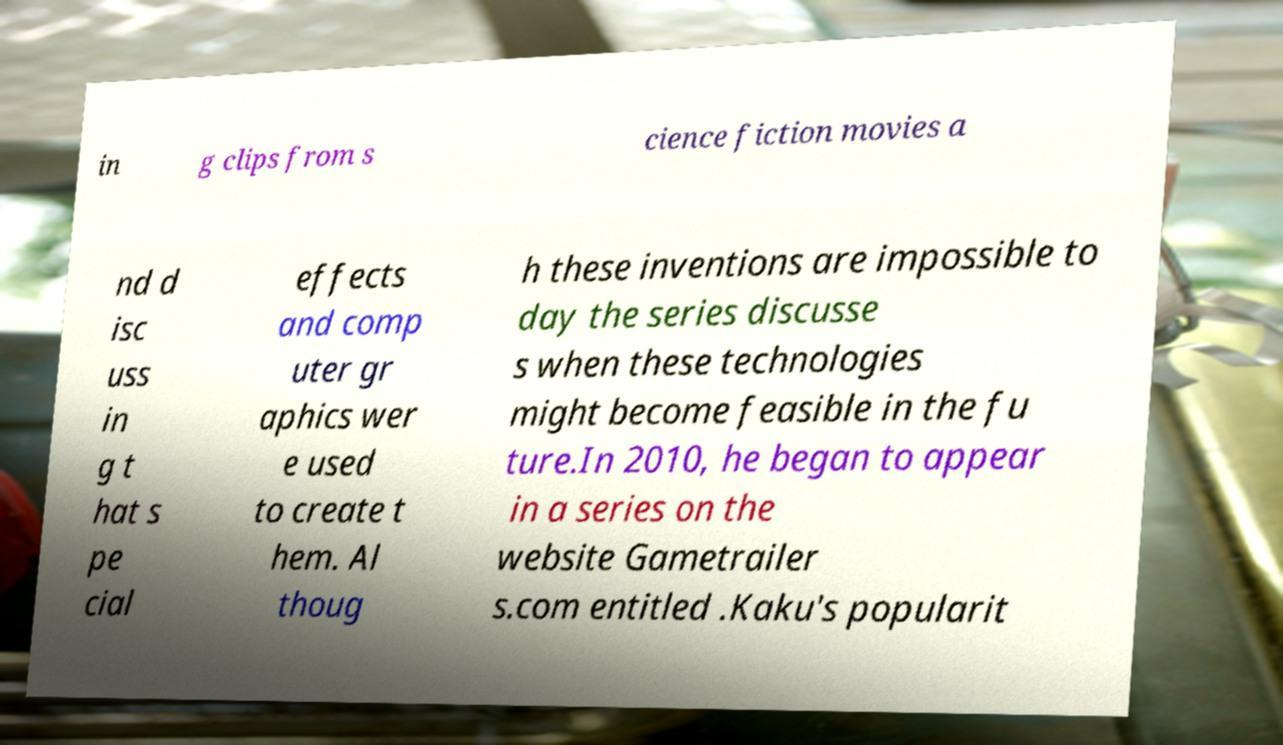I need the written content from this picture converted into text. Can you do that? in g clips from s cience fiction movies a nd d isc uss in g t hat s pe cial effects and comp uter gr aphics wer e used to create t hem. Al thoug h these inventions are impossible to day the series discusse s when these technologies might become feasible in the fu ture.In 2010, he began to appear in a series on the website Gametrailer s.com entitled .Kaku's popularit 